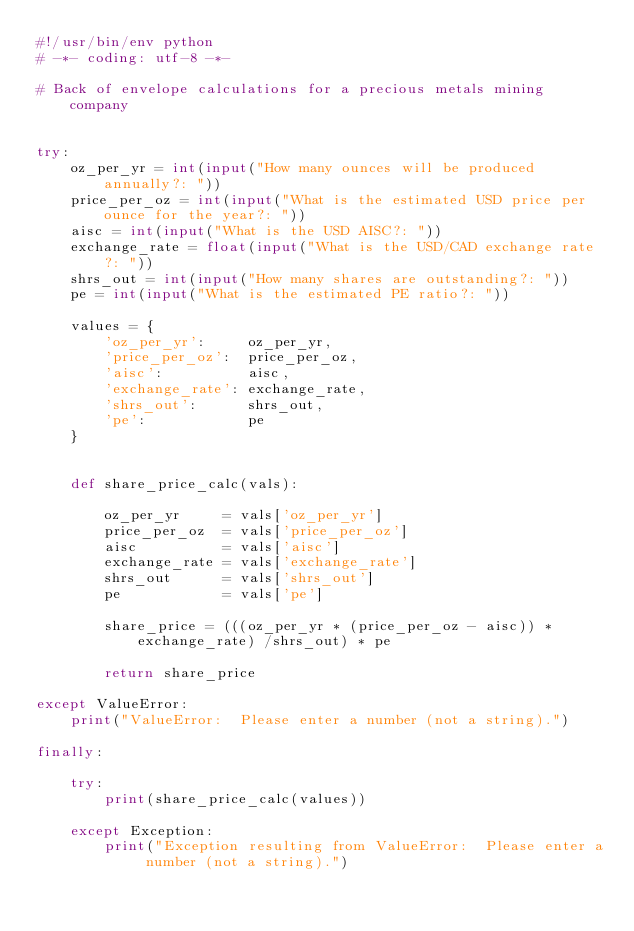<code> <loc_0><loc_0><loc_500><loc_500><_Python_>#!/usr/bin/env python
# -*- coding: utf-8 -*-

# Back of envelope calculations for a precious metals mining company


try:
    oz_per_yr = int(input("How many ounces will be produced annually?: "))
    price_per_oz = int(input("What is the estimated USD price per ounce for the year?: "))
    aisc = int(input("What is the USD AISC?: "))
    exchange_rate = float(input("What is the USD/CAD exchange rate?: "))
    shrs_out = int(input("How many shares are outstanding?: "))
    pe = int(input("What is the estimated PE ratio?: "))

    values = {
        'oz_per_yr':     oz_per_yr,
        'price_per_oz':  price_per_oz,
        'aisc':          aisc,
        'exchange_rate': exchange_rate,
        'shrs_out':      shrs_out,
        'pe':            pe
    }


    def share_price_calc(vals):

        oz_per_yr     = vals['oz_per_yr']
        price_per_oz  = vals['price_per_oz']
        aisc          = vals['aisc']
        exchange_rate = vals['exchange_rate']
        shrs_out      = vals['shrs_out']
        pe            = vals['pe']

        share_price = (((oz_per_yr * (price_per_oz - aisc)) * exchange_rate) /shrs_out) * pe

        return share_price

except ValueError:
    print("ValueError:  Please enter a number (not a string).")

finally:

    try:
        print(share_price_calc(values))

    except Exception:
        print("Exception resulting from ValueError:  Please enter a number (not a string).")
</code> 